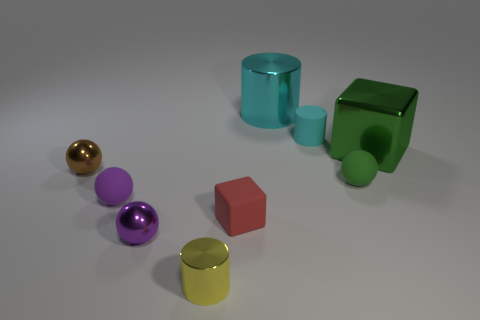How many other things are the same size as the purple matte object?
Ensure brevity in your answer.  6. There is a tiny brown object; are there any cubes behind it?
Provide a short and direct response. Yes. Is the size of the yellow object the same as the red thing?
Your answer should be compact. Yes. The big thing on the left side of the large green block has what shape?
Offer a terse response. Cylinder. Is there a yellow object that has the same size as the cyan rubber cylinder?
Provide a succinct answer. Yes. There is a brown thing that is the same size as the yellow metallic thing; what is its material?
Your answer should be very brief. Metal. How big is the purple object that is in front of the small purple matte ball?
Keep it short and to the point. Small. The green shiny thing has what size?
Provide a succinct answer. Large. Is the size of the green matte ball the same as the rubber thing left of the yellow shiny thing?
Make the answer very short. Yes. The metal sphere in front of the sphere that is to the right of the large cyan cylinder is what color?
Give a very brief answer. Purple. 